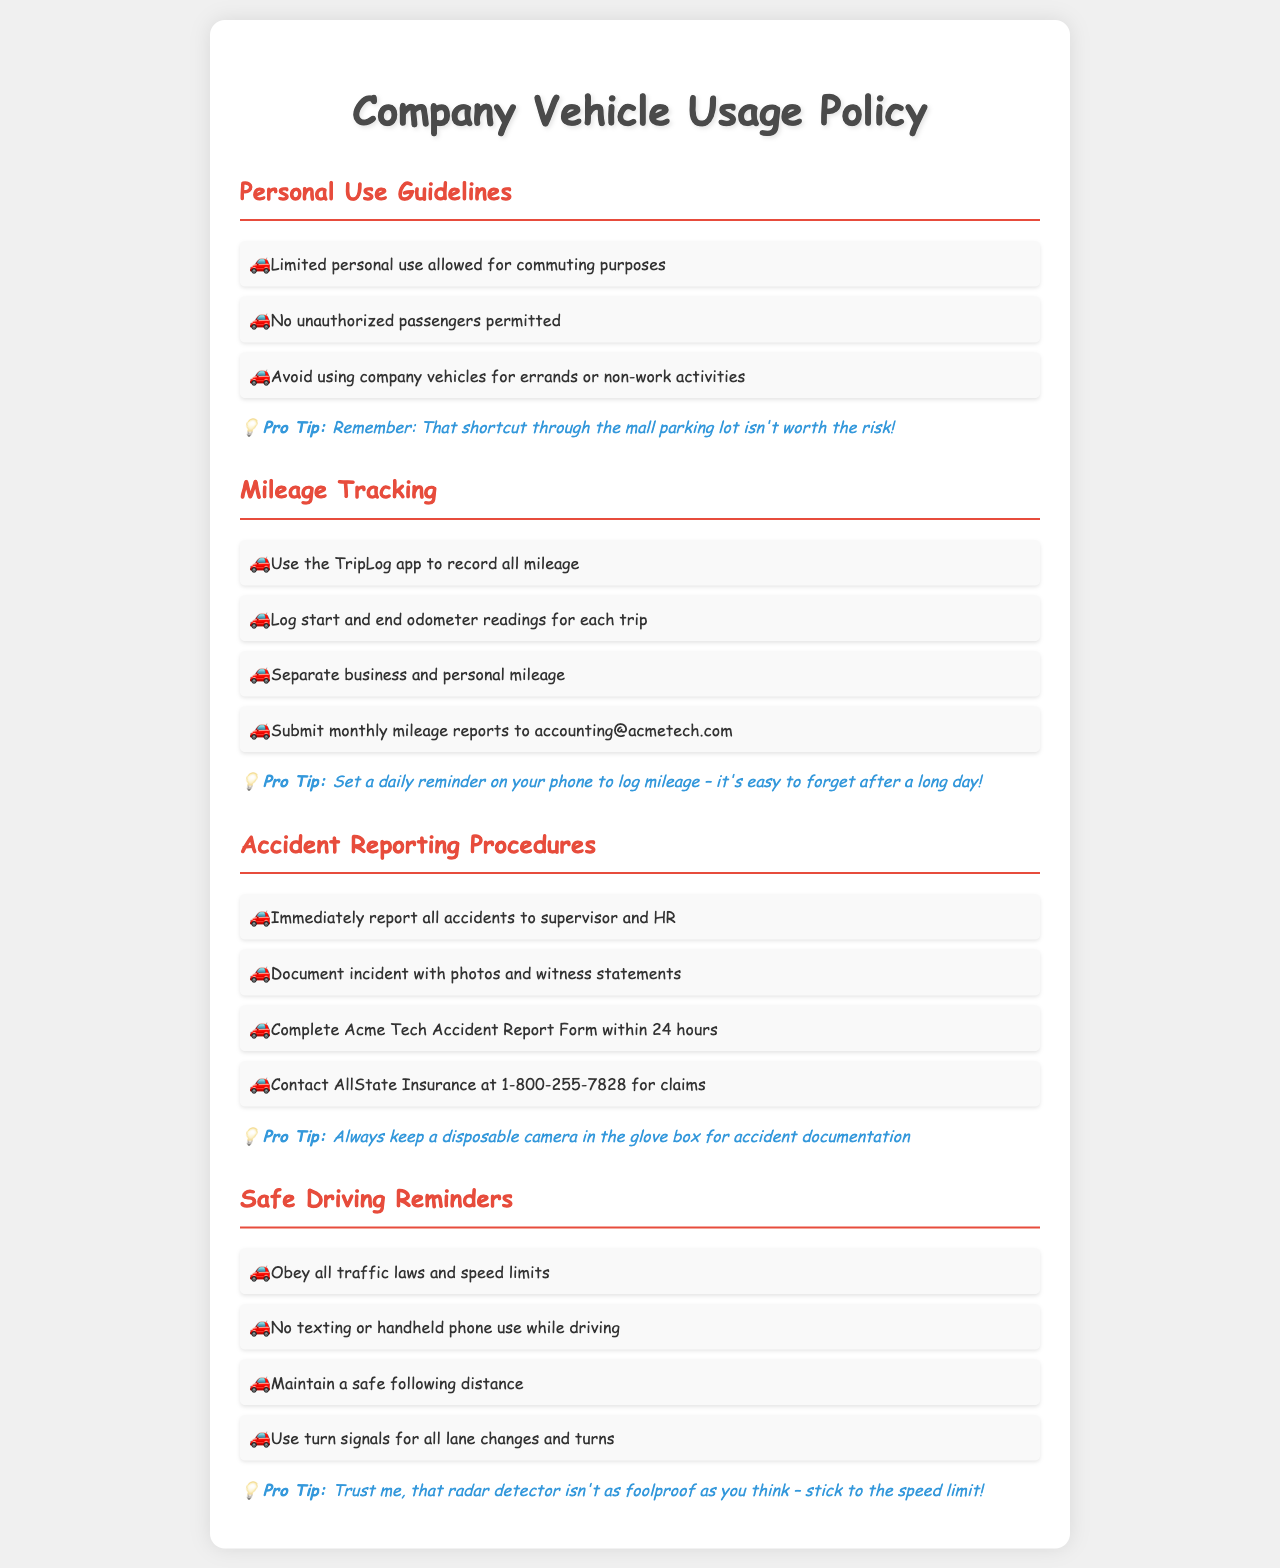What is allowed for personal use of company vehicles? The document states that limited personal use is allowed for commuting purposes.
Answer: Limited personal use for commuting What should be used to track mileage? The policy specifies the use of the TripLog app for mileage tracking.
Answer: TripLog app What is the timeframe to complete the Accident Report Form? The document indicates that the form must be completed within 24 hours of the accident.
Answer: 24 hours What must you do immediately after an accident? According to the document, all accidents must be reported to the supervisor and HR.
Answer: Report to supervisor and HR What is prohibited while driving? The document states that no texting or handheld phone use is allowed while driving.
Answer: No texting or handheld phone use What should be separated when logging mileage? The policy emphasizes the need to separate business and personal mileage when logging.
Answer: Business and personal mileage What insurance company should be contacted for claims? The document specifies contacting AllState Insurance for claims related to accidents.
Answer: AllState Insurance What is a recommended reminder for logging mileage? The tip suggests setting a daily reminder on your phone to log mileage.
Answer: Daily reminder on your phone How should incident documentation be completed after an accident? The document advises to document the incident with photos and witness statements.
Answer: Photos and witness statements 